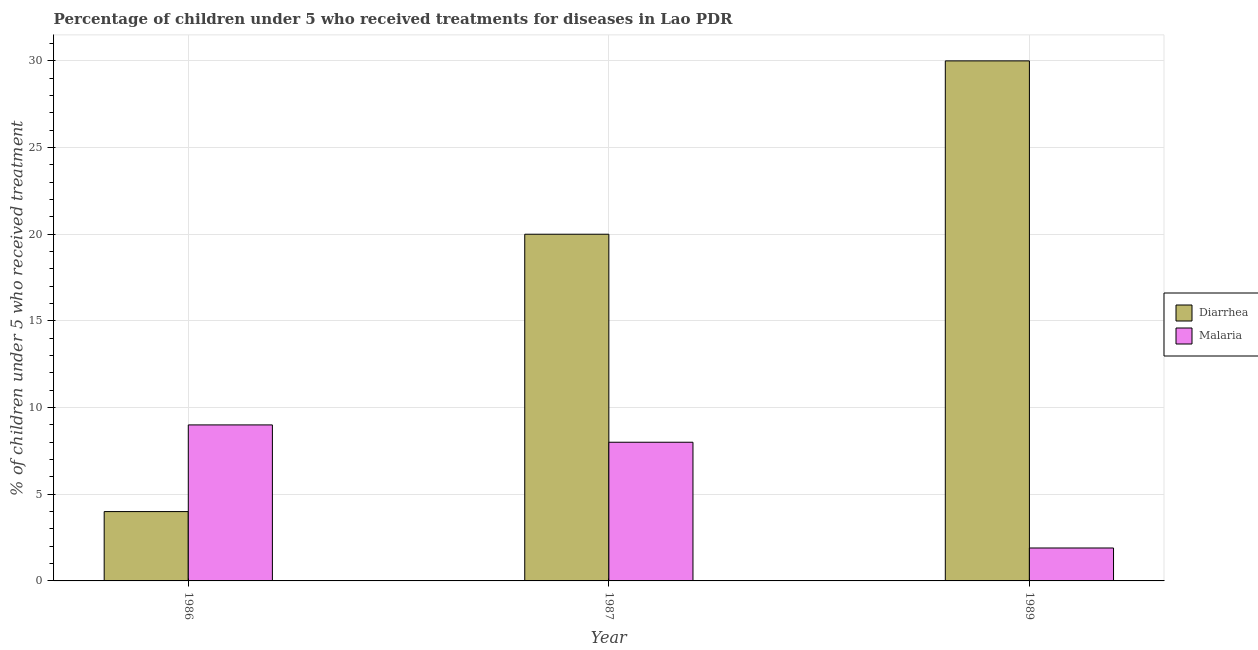How many different coloured bars are there?
Offer a very short reply. 2. Are the number of bars per tick equal to the number of legend labels?
Make the answer very short. Yes. What is the percentage of children who received treatment for diarrhoea in 1989?
Offer a terse response. 30. In which year was the percentage of children who received treatment for diarrhoea minimum?
Your response must be concise. 1986. What is the total percentage of children who received treatment for malaria in the graph?
Your response must be concise. 18.9. What is the difference between the percentage of children who received treatment for diarrhoea in 1987 and that in 1989?
Provide a short and direct response. -10. What is the difference between the percentage of children who received treatment for diarrhoea in 1986 and the percentage of children who received treatment for malaria in 1987?
Keep it short and to the point. -16. What is the ratio of the percentage of children who received treatment for diarrhoea in 1986 to that in 1989?
Make the answer very short. 0.13. Is the percentage of children who received treatment for diarrhoea in 1986 less than that in 1987?
Ensure brevity in your answer.  Yes. What is the difference between the highest and the second highest percentage of children who received treatment for malaria?
Offer a very short reply. 1. What is the difference between the highest and the lowest percentage of children who received treatment for diarrhoea?
Your response must be concise. 26. What does the 2nd bar from the left in 1986 represents?
Your answer should be compact. Malaria. What does the 2nd bar from the right in 1986 represents?
Provide a succinct answer. Diarrhea. Are all the bars in the graph horizontal?
Give a very brief answer. No. How many years are there in the graph?
Offer a very short reply. 3. What is the difference between two consecutive major ticks on the Y-axis?
Keep it short and to the point. 5. Does the graph contain any zero values?
Offer a very short reply. No. Where does the legend appear in the graph?
Give a very brief answer. Center right. How many legend labels are there?
Offer a terse response. 2. What is the title of the graph?
Give a very brief answer. Percentage of children under 5 who received treatments for diseases in Lao PDR. What is the label or title of the Y-axis?
Your answer should be compact. % of children under 5 who received treatment. Across all years, what is the maximum % of children under 5 who received treatment in Diarrhea?
Make the answer very short. 30. Across all years, what is the minimum % of children under 5 who received treatment of Malaria?
Offer a terse response. 1.9. What is the total % of children under 5 who received treatment in Diarrhea in the graph?
Your answer should be very brief. 54. What is the total % of children under 5 who received treatment in Malaria in the graph?
Provide a succinct answer. 18.9. What is the difference between the % of children under 5 who received treatment in Malaria in 1986 and that in 1987?
Offer a very short reply. 1. What is the difference between the % of children under 5 who received treatment of Diarrhea in 1986 and that in 1989?
Your answer should be compact. -26. What is the difference between the % of children under 5 who received treatment of Diarrhea in 1987 and that in 1989?
Provide a short and direct response. -10. What is the difference between the % of children under 5 who received treatment in Malaria in 1987 and that in 1989?
Your answer should be compact. 6.1. What is the difference between the % of children under 5 who received treatment of Diarrhea in 1986 and the % of children under 5 who received treatment of Malaria in 1989?
Your answer should be compact. 2.1. What is the average % of children under 5 who received treatment of Diarrhea per year?
Your response must be concise. 18. What is the average % of children under 5 who received treatment in Malaria per year?
Offer a very short reply. 6.3. In the year 1987, what is the difference between the % of children under 5 who received treatment in Diarrhea and % of children under 5 who received treatment in Malaria?
Offer a terse response. 12. In the year 1989, what is the difference between the % of children under 5 who received treatment of Diarrhea and % of children under 5 who received treatment of Malaria?
Give a very brief answer. 28.1. What is the ratio of the % of children under 5 who received treatment in Diarrhea in 1986 to that in 1987?
Offer a very short reply. 0.2. What is the ratio of the % of children under 5 who received treatment in Diarrhea in 1986 to that in 1989?
Give a very brief answer. 0.13. What is the ratio of the % of children under 5 who received treatment of Malaria in 1986 to that in 1989?
Provide a short and direct response. 4.74. What is the ratio of the % of children under 5 who received treatment in Malaria in 1987 to that in 1989?
Your answer should be compact. 4.21. What is the difference between the highest and the second highest % of children under 5 who received treatment in Diarrhea?
Your answer should be compact. 10. What is the difference between the highest and the lowest % of children under 5 who received treatment of Malaria?
Offer a very short reply. 7.1. 